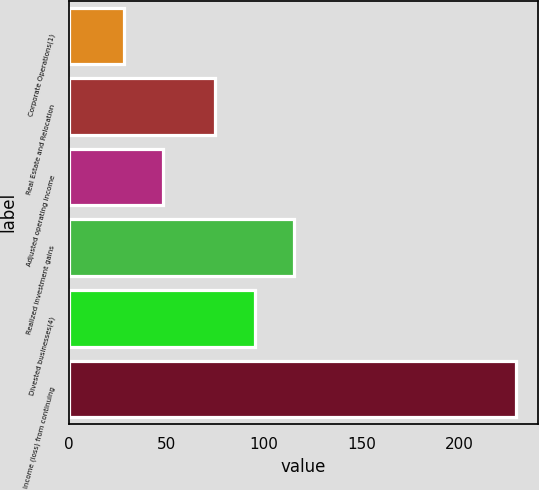Convert chart to OTSL. <chart><loc_0><loc_0><loc_500><loc_500><bar_chart><fcel>Corporate Operations(1)<fcel>Real Estate and Relocation<fcel>Adjusted operating income<fcel>Realized investment gains<fcel>Divested businesses(4)<fcel>Income (loss) from continuing<nl><fcel>28<fcel>75<fcel>48.1<fcel>115.2<fcel>95.1<fcel>229<nl></chart> 